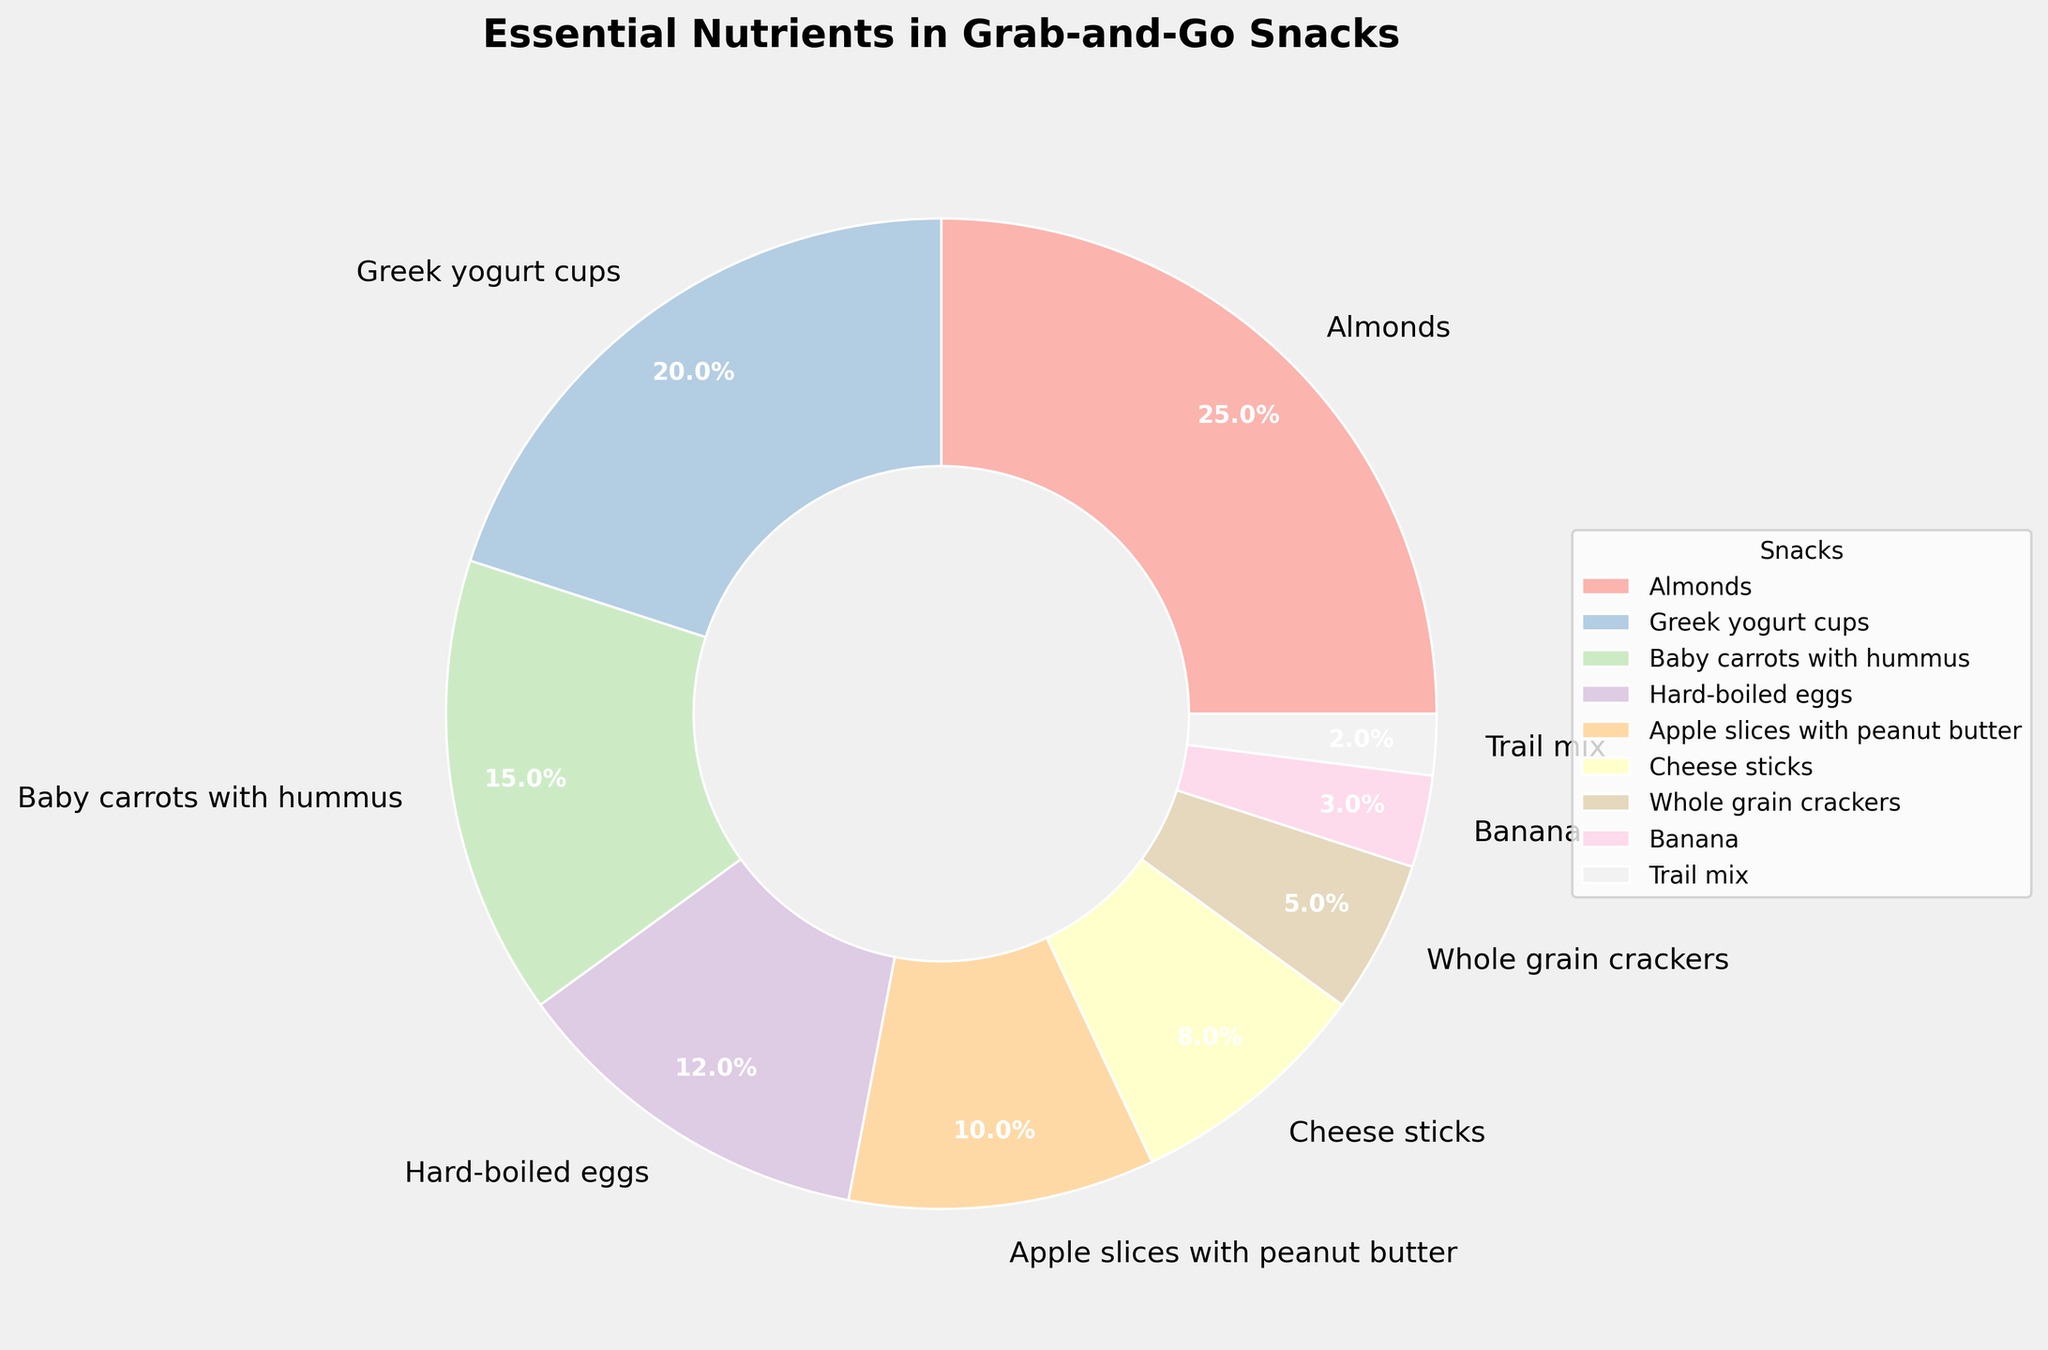Which snack has the highest percentage of essential nutrients? By examining the pie chart, we see that Almonds occupy the largest segment. Therefore, Almonds have the highest percentage of essential nutrients.
Answer: Almonds Which snack has the smallest percentage of essential nutrients? We need to look at the smallest segment in the pie chart, which belongs to Trail mix.
Answer: Trail mix Do Greek yogurt cups and Baby carrots with hummus together provide more than or less than 30% of essential nutrients? First, identify the segments: Greek yogurt cups (20%) and Baby carrots with hummus (15%). Together, they sum up to 20% + 15% = 35%. Thus, they provide more than 30% of essential nutrients.
Answer: More than 30% Is the percentage of essential nutrients from Hard-boiled eggs greater than that from Cheese sticks? Comparing the segments, Hard-boiled eggs (12%) versus Cheese sticks (8%), we see that 12% is indeed greater than 8%.
Answer: Yes How much more is the percentage of essential nutrients from Apple slices with peanut butter compared to Banana? Apple slices with peanut butter (10%) and Banana (3%) show a difference of 10% - 3% = 7%.
Answer: 7% What is the combined percentage of essential nutrients from the top three snacks? The top three snacks are Almonds (25%), Greek yogurt cups (20%), and Baby carrots with hummus (15%). The combined total is 25% + 20% + 15% = 60%.
Answer: 60% Which snacks have a percentage of essential nutrients less than 10%? By examining the pie chart segments, we find that Cheese sticks (8%), Whole grain crackers (5%), Banana (3%), and Trail mix (2%) all have less than 10%.
Answer: Cheese sticks, Whole grain crackers, Banana, Trail mix What is the average percentage of essential nutrients provided by Cheese sticks, Whole grain crackers, and Banana? These snacks have percentages of 8%, 5%, and 3%, respectively. Their total is 8% + 5% + 3% = 16%, and the average is 16% / 3 ≈ 5.3%.
Answer: ≈ 5.3% Which snack contributes exactly 12% of essential nutrients, and what color represents it in the pie chart? Hard-boiled eggs contribute exactly 12% and are represented by a pastel color. The specific color can be confirmed by looking at the pie chart legend.
Answer: Hard-boiled eggs, pastel color 